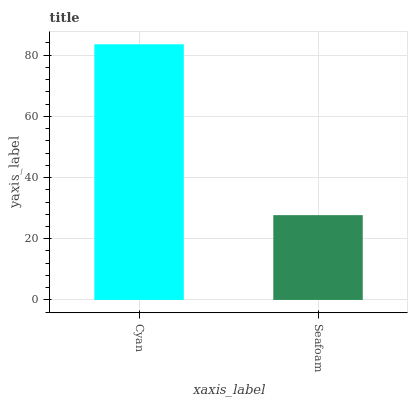Is Seafoam the minimum?
Answer yes or no. Yes. Is Cyan the maximum?
Answer yes or no. Yes. Is Seafoam the maximum?
Answer yes or no. No. Is Cyan greater than Seafoam?
Answer yes or no. Yes. Is Seafoam less than Cyan?
Answer yes or no. Yes. Is Seafoam greater than Cyan?
Answer yes or no. No. Is Cyan less than Seafoam?
Answer yes or no. No. Is Cyan the high median?
Answer yes or no. Yes. Is Seafoam the low median?
Answer yes or no. Yes. Is Seafoam the high median?
Answer yes or no. No. Is Cyan the low median?
Answer yes or no. No. 